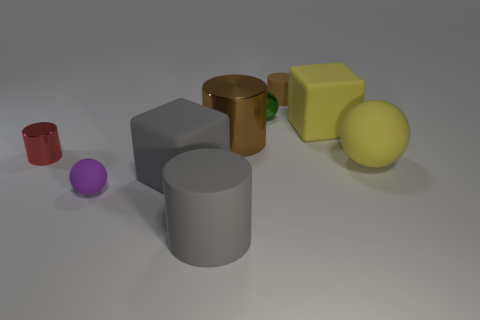Does the small shiny thing that is behind the large yellow block have the same shape as the small matte thing behind the big shiny thing?
Offer a very short reply. No. What is the material of the big gray thing that is the same shape as the tiny red metallic object?
Provide a short and direct response. Rubber. What is the color of the rubber object that is both on the right side of the small brown matte object and behind the big matte ball?
Give a very brief answer. Yellow. Are there any big matte cylinders behind the tiny shiny thing right of the small object in front of the tiny red shiny object?
Make the answer very short. No. How many objects are either metal objects or big red metal balls?
Give a very brief answer. 3. Is the material of the red cylinder the same as the purple object that is to the left of the gray cylinder?
Ensure brevity in your answer.  No. Is there any other thing that is the same color as the large ball?
Your response must be concise. Yes. What number of objects are either purple spheres on the right side of the small red metal object or rubber cubes that are to the right of the metal sphere?
Provide a short and direct response. 2. The matte object that is both behind the tiny metal cylinder and in front of the green ball has what shape?
Provide a succinct answer. Cube. There is a matte cube behind the red cylinder; what number of yellow cubes are on the right side of it?
Make the answer very short. 0. 